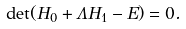<formula> <loc_0><loc_0><loc_500><loc_500>\det ( H _ { 0 } + \Lambda H _ { 1 } - E ) = 0 .</formula> 